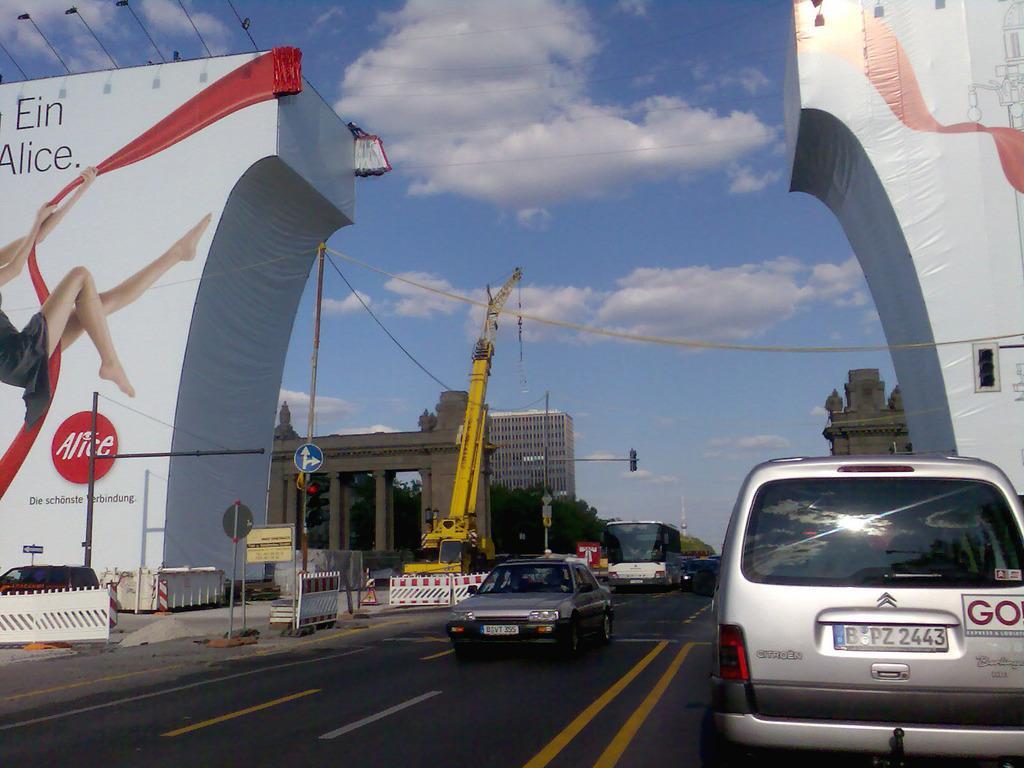In one or two sentences, can you explain what this image depicts? In this picture we can see vehicles on the road. Here we can see poles, boards, hoardings, traffic signal, crane, pillars, trees, and buildings. In the background there is sky with clouds. 